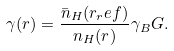Convert formula to latex. <formula><loc_0><loc_0><loc_500><loc_500>\gamma ( r ) = \frac { \bar { n } _ { H } ( r _ { r } e f ) } { n _ { H } ( r ) } \gamma _ { B } G .</formula> 